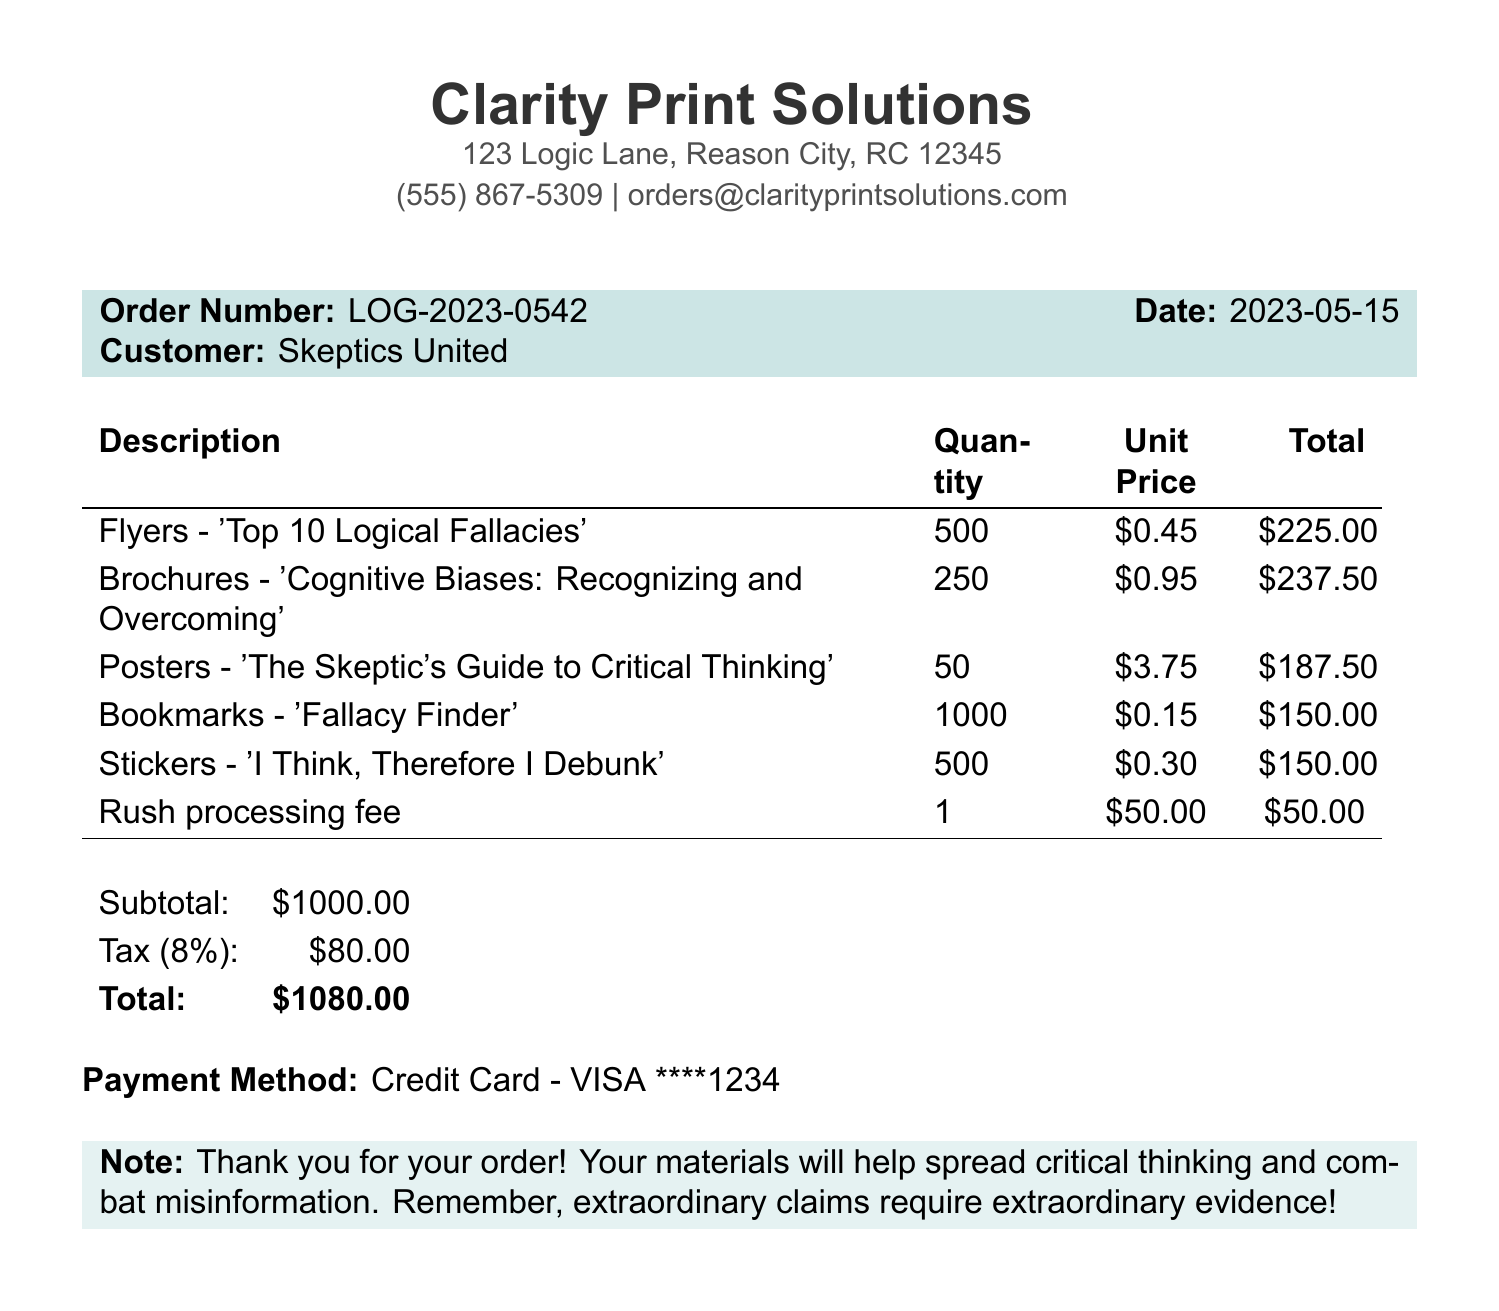What is the business name? The business name is located at the top of the document.
Answer: Clarity Print Solutions What is the order number? The order number is specified in the highlighted section of the document.
Answer: LOG-2023-0542 What is the total amount charged? The total amount charged can be found in the totals section of the document.
Answer: $1080.00 How many flyers were ordered? The quantity for the flyers is detailed in the itemized list.
Answer: 500 What is the unit price of the brochures? The unit price of the brochures is listed in the table of items.
Answer: $0.95 What is the tax rate applied? The tax rate is specified in the totals section of the document.
Answer: 8% What is the email address for the print shop? The email address can be found at the top part of the document.
Answer: orders@clarityprintsolutions.com What is the rush processing fee? The rush processing fee is mentioned in the itemized bill.
Answer: $50.00 How many bookmarks were ordered? The quantity for bookmarks is included in the itemized section of the receipt.
Answer: 1000 